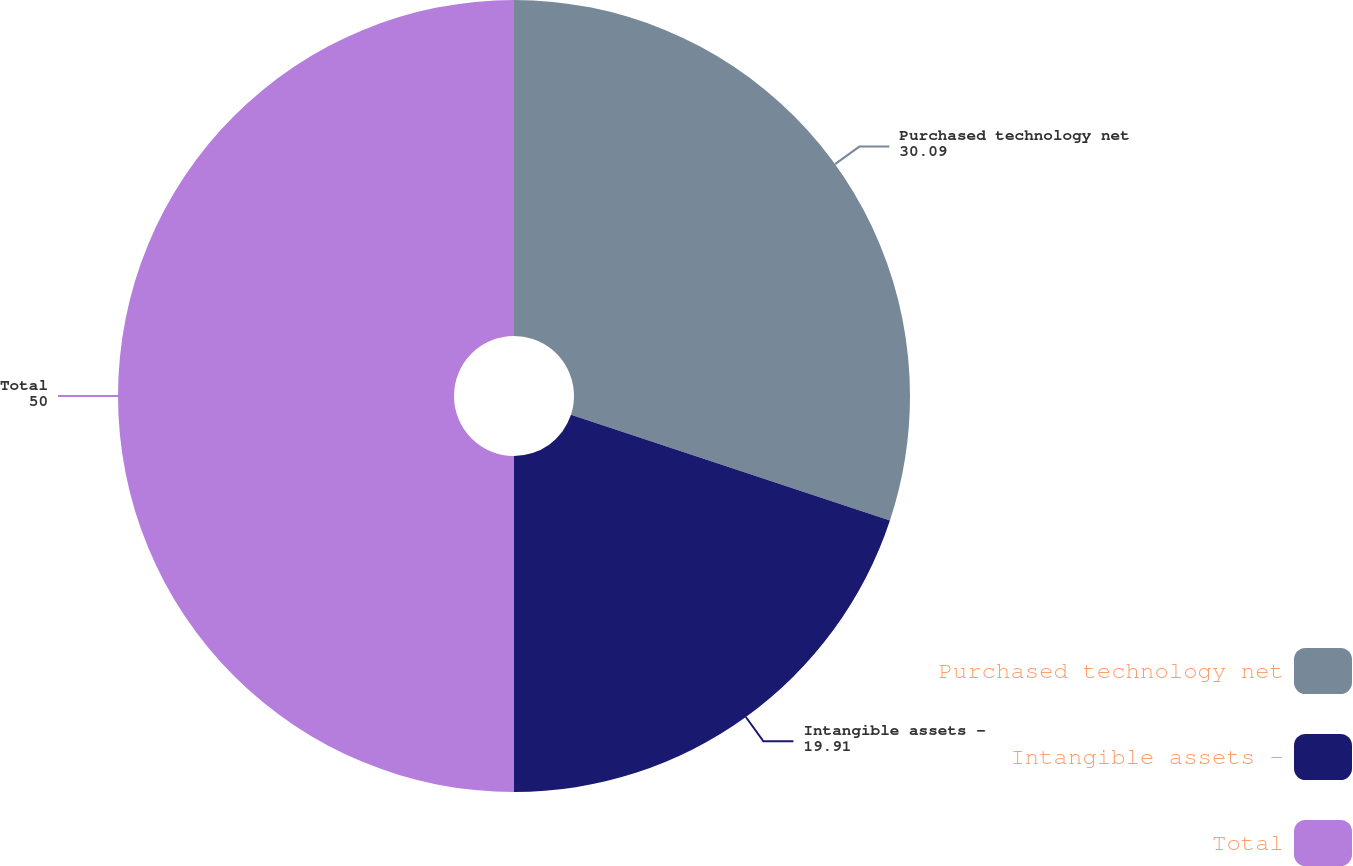<chart> <loc_0><loc_0><loc_500><loc_500><pie_chart><fcel>Purchased technology net<fcel>Intangible assets -<fcel>Total<nl><fcel>30.09%<fcel>19.91%<fcel>50.0%<nl></chart> 